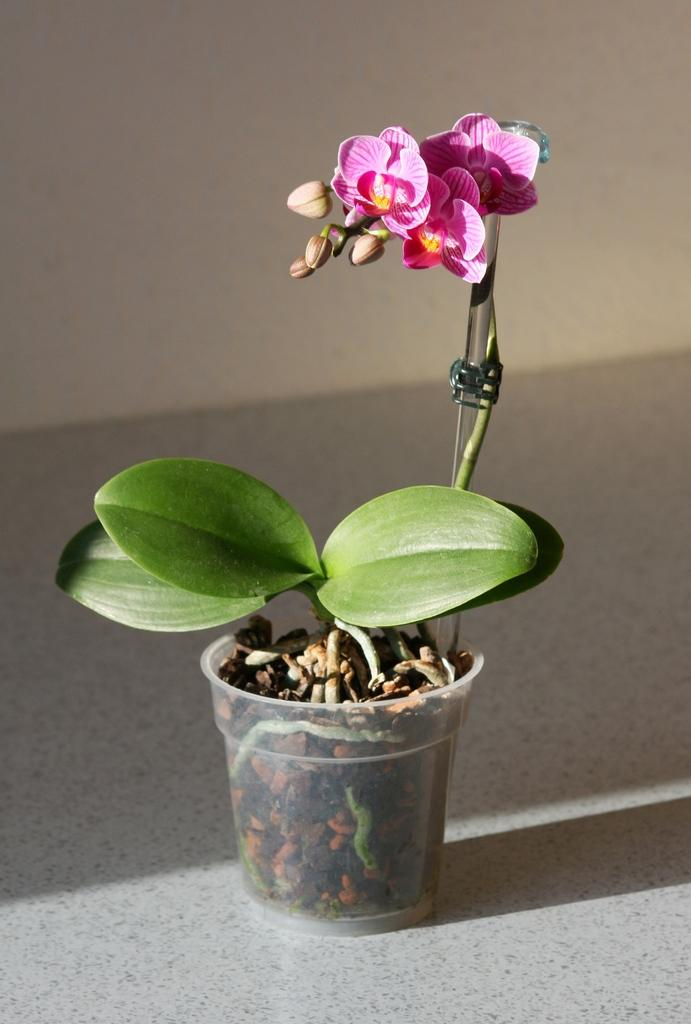What is the main subject in the center of the image? There is a flower pot plant in the center of the image. What type of plants can be seen in the image? There are flowers in the image. What is visible at the bottom of the image? There is a floor visible at the bottom of the image. What can be seen in the background of the image? There is a wall in the background of the image. How many babies are crawling on the floor in the image? There are no babies present in the image; it features a flower pot plant and flowers. What is the smell of the flowers in the image? The image does not provide information about the smell of the flowers, as it only shows a visual representation. 